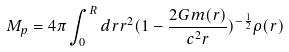Convert formula to latex. <formula><loc_0><loc_0><loc_500><loc_500>M _ { p } = 4 \pi \int _ { 0 } ^ { R } d r r ^ { 2 } ( 1 - \frac { 2 G m ( r ) } { c ^ { 2 } r } ) ^ { - \frac { 1 } { 2 } } \rho ( r )</formula> 